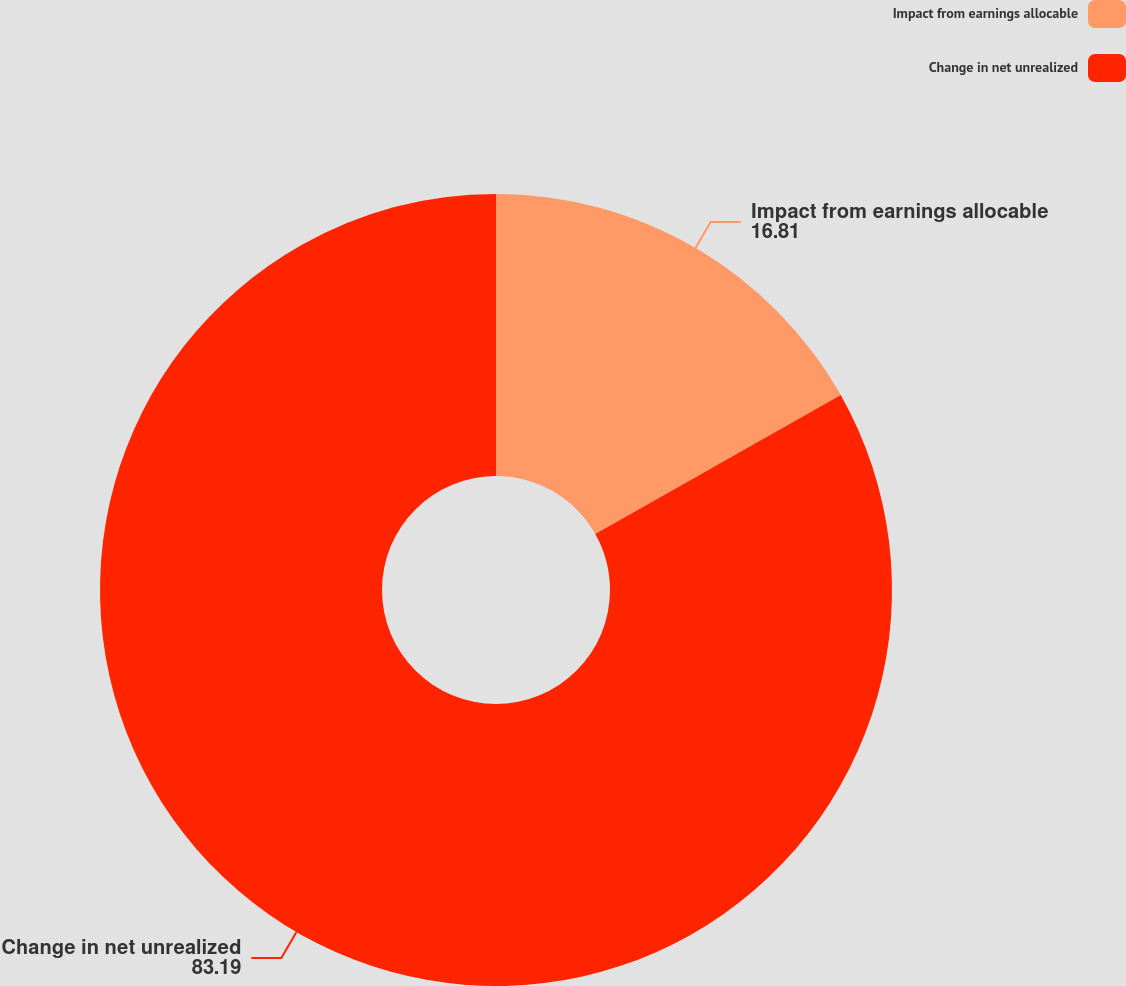<chart> <loc_0><loc_0><loc_500><loc_500><pie_chart><fcel>Impact from earnings allocable<fcel>Change in net unrealized<nl><fcel>16.81%<fcel>83.19%<nl></chart> 